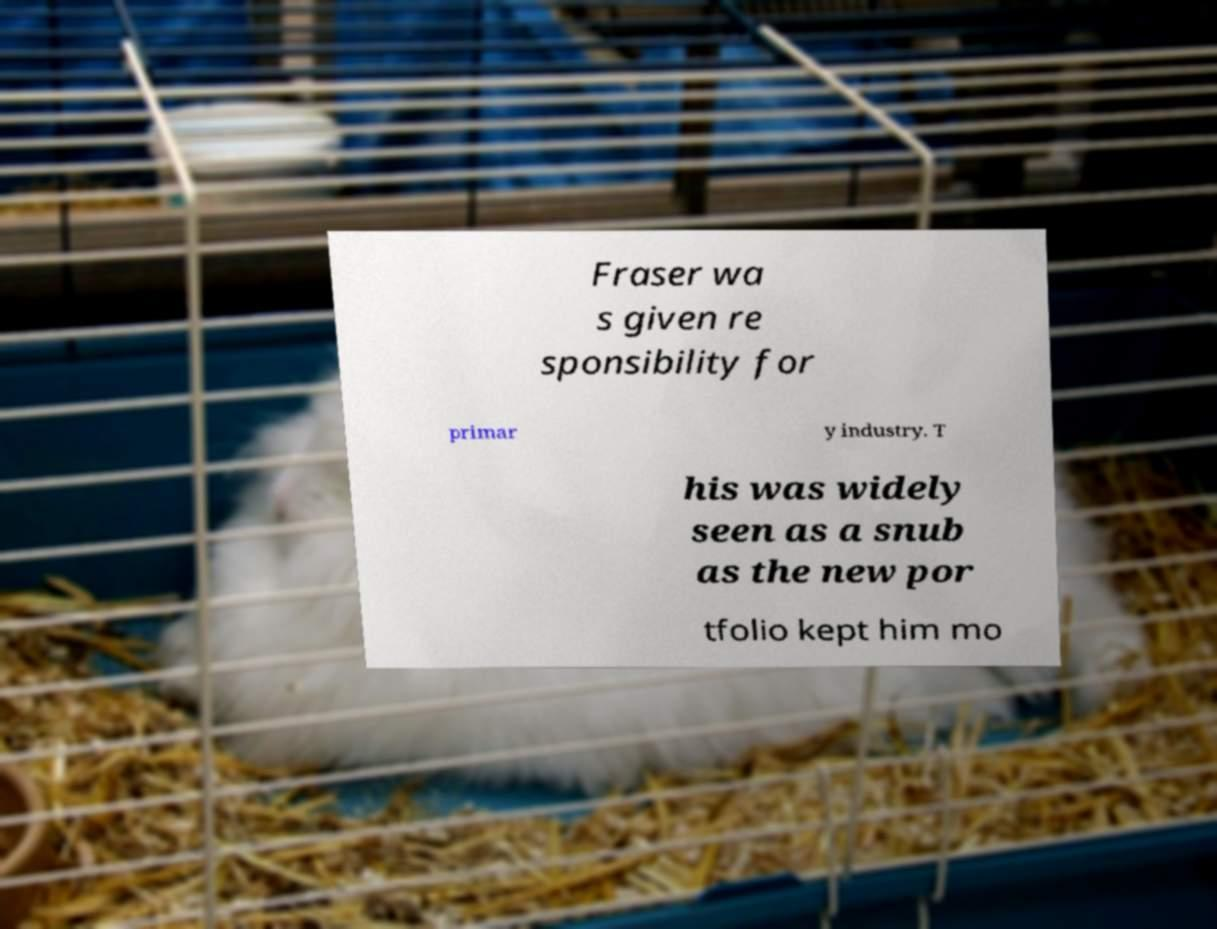There's text embedded in this image that I need extracted. Can you transcribe it verbatim? Fraser wa s given re sponsibility for primar y industry. T his was widely seen as a snub as the new por tfolio kept him mo 